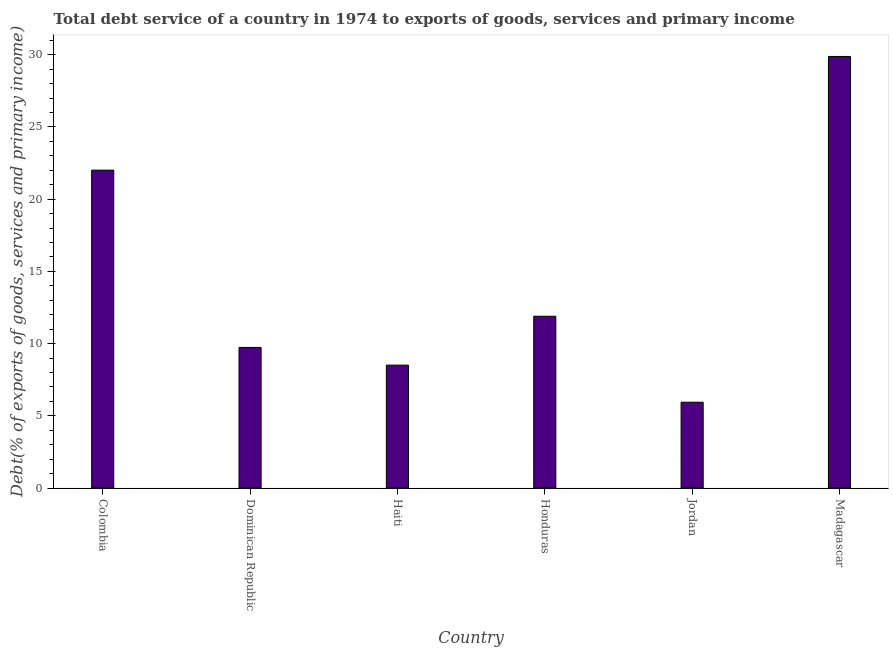Does the graph contain any zero values?
Keep it short and to the point. No. What is the title of the graph?
Ensure brevity in your answer.  Total debt service of a country in 1974 to exports of goods, services and primary income. What is the label or title of the X-axis?
Offer a very short reply. Country. What is the label or title of the Y-axis?
Provide a succinct answer. Debt(% of exports of goods, services and primary income). What is the total debt service in Honduras?
Ensure brevity in your answer.  11.9. Across all countries, what is the maximum total debt service?
Offer a very short reply. 29.88. Across all countries, what is the minimum total debt service?
Your answer should be compact. 5.94. In which country was the total debt service maximum?
Your answer should be compact. Madagascar. In which country was the total debt service minimum?
Make the answer very short. Jordan. What is the sum of the total debt service?
Ensure brevity in your answer.  87.97. What is the difference between the total debt service in Dominican Republic and Honduras?
Give a very brief answer. -2.16. What is the average total debt service per country?
Ensure brevity in your answer.  14.66. What is the median total debt service?
Ensure brevity in your answer.  10.82. What is the ratio of the total debt service in Dominican Republic to that in Madagascar?
Provide a short and direct response. 0.33. What is the difference between the highest and the second highest total debt service?
Your answer should be compact. 7.87. What is the difference between the highest and the lowest total debt service?
Provide a succinct answer. 23.93. How many bars are there?
Offer a terse response. 6. Are all the bars in the graph horizontal?
Your answer should be very brief. No. How many countries are there in the graph?
Give a very brief answer. 6. What is the difference between two consecutive major ticks on the Y-axis?
Offer a terse response. 5. What is the Debt(% of exports of goods, services and primary income) in Colombia?
Your response must be concise. 22.01. What is the Debt(% of exports of goods, services and primary income) of Dominican Republic?
Keep it short and to the point. 9.74. What is the Debt(% of exports of goods, services and primary income) of Haiti?
Give a very brief answer. 8.51. What is the Debt(% of exports of goods, services and primary income) of Honduras?
Offer a very short reply. 11.9. What is the Debt(% of exports of goods, services and primary income) in Jordan?
Offer a very short reply. 5.94. What is the Debt(% of exports of goods, services and primary income) of Madagascar?
Offer a terse response. 29.88. What is the difference between the Debt(% of exports of goods, services and primary income) in Colombia and Dominican Republic?
Make the answer very short. 12.27. What is the difference between the Debt(% of exports of goods, services and primary income) in Colombia and Haiti?
Give a very brief answer. 13.5. What is the difference between the Debt(% of exports of goods, services and primary income) in Colombia and Honduras?
Provide a succinct answer. 10.11. What is the difference between the Debt(% of exports of goods, services and primary income) in Colombia and Jordan?
Offer a very short reply. 16.06. What is the difference between the Debt(% of exports of goods, services and primary income) in Colombia and Madagascar?
Your response must be concise. -7.87. What is the difference between the Debt(% of exports of goods, services and primary income) in Dominican Republic and Haiti?
Keep it short and to the point. 1.22. What is the difference between the Debt(% of exports of goods, services and primary income) in Dominican Republic and Honduras?
Make the answer very short. -2.16. What is the difference between the Debt(% of exports of goods, services and primary income) in Dominican Republic and Jordan?
Keep it short and to the point. 3.79. What is the difference between the Debt(% of exports of goods, services and primary income) in Dominican Republic and Madagascar?
Make the answer very short. -20.14. What is the difference between the Debt(% of exports of goods, services and primary income) in Haiti and Honduras?
Your answer should be compact. -3.38. What is the difference between the Debt(% of exports of goods, services and primary income) in Haiti and Jordan?
Ensure brevity in your answer.  2.57. What is the difference between the Debt(% of exports of goods, services and primary income) in Haiti and Madagascar?
Provide a succinct answer. -21.37. What is the difference between the Debt(% of exports of goods, services and primary income) in Honduras and Jordan?
Your answer should be compact. 5.95. What is the difference between the Debt(% of exports of goods, services and primary income) in Honduras and Madagascar?
Make the answer very short. -17.98. What is the difference between the Debt(% of exports of goods, services and primary income) in Jordan and Madagascar?
Offer a very short reply. -23.93. What is the ratio of the Debt(% of exports of goods, services and primary income) in Colombia to that in Dominican Republic?
Your answer should be compact. 2.26. What is the ratio of the Debt(% of exports of goods, services and primary income) in Colombia to that in Haiti?
Keep it short and to the point. 2.59. What is the ratio of the Debt(% of exports of goods, services and primary income) in Colombia to that in Honduras?
Your answer should be very brief. 1.85. What is the ratio of the Debt(% of exports of goods, services and primary income) in Colombia to that in Jordan?
Give a very brief answer. 3.7. What is the ratio of the Debt(% of exports of goods, services and primary income) in Colombia to that in Madagascar?
Your response must be concise. 0.74. What is the ratio of the Debt(% of exports of goods, services and primary income) in Dominican Republic to that in Haiti?
Offer a very short reply. 1.14. What is the ratio of the Debt(% of exports of goods, services and primary income) in Dominican Republic to that in Honduras?
Keep it short and to the point. 0.82. What is the ratio of the Debt(% of exports of goods, services and primary income) in Dominican Republic to that in Jordan?
Keep it short and to the point. 1.64. What is the ratio of the Debt(% of exports of goods, services and primary income) in Dominican Republic to that in Madagascar?
Your response must be concise. 0.33. What is the ratio of the Debt(% of exports of goods, services and primary income) in Haiti to that in Honduras?
Offer a terse response. 0.71. What is the ratio of the Debt(% of exports of goods, services and primary income) in Haiti to that in Jordan?
Your answer should be very brief. 1.43. What is the ratio of the Debt(% of exports of goods, services and primary income) in Haiti to that in Madagascar?
Provide a short and direct response. 0.28. What is the ratio of the Debt(% of exports of goods, services and primary income) in Honduras to that in Jordan?
Offer a very short reply. 2. What is the ratio of the Debt(% of exports of goods, services and primary income) in Honduras to that in Madagascar?
Provide a short and direct response. 0.4. What is the ratio of the Debt(% of exports of goods, services and primary income) in Jordan to that in Madagascar?
Keep it short and to the point. 0.2. 